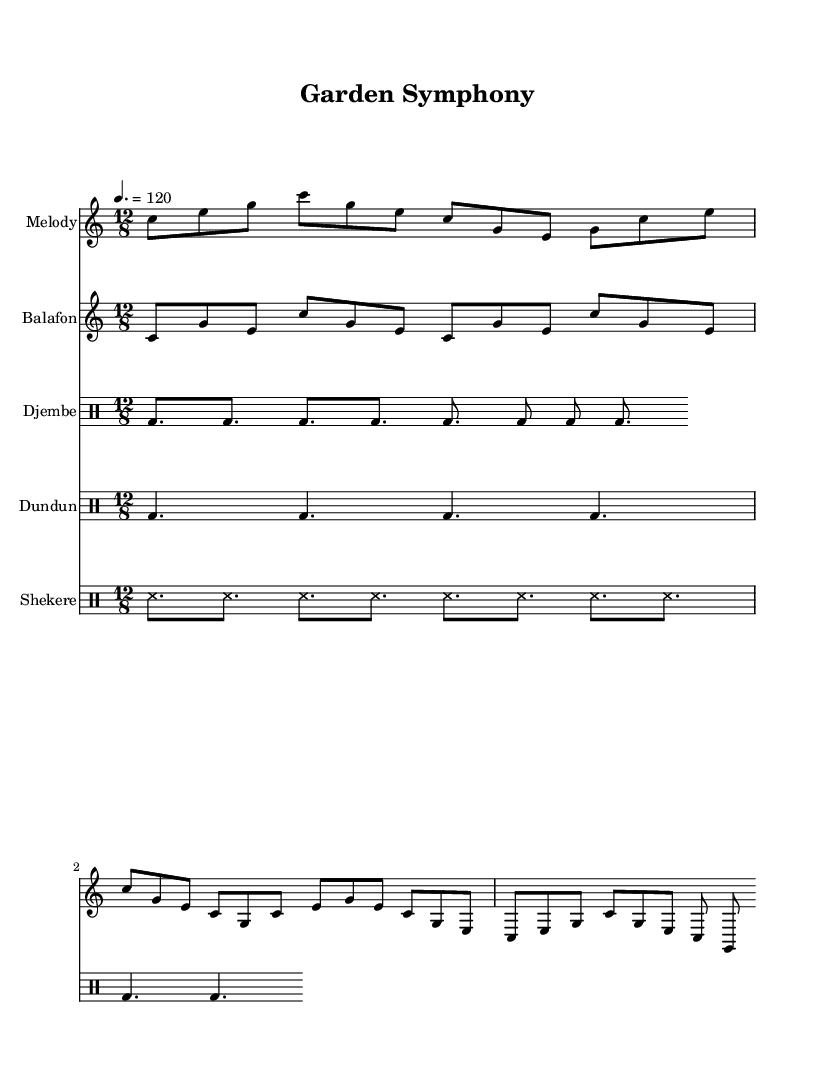What is the key signature of this music? The key signature is C major, which has no sharps or flats.
Answer: C major What is the time signature of this piece? The time signature is 12/8, indicating a compound meter with 12 eighth notes per measure.
Answer: 12/8 What is the tempo marking for this music? The tempo marking indicates a speed of 120 beats per minute, which sets a lively pace for the performance.
Answer: 120 How many different instruments are featured in the score? There are five different instruments featured in the score: Melody, Balafon, Djembe, Dundun, and Shekere, indicating a rich and varied texture.
Answer: Five What is the name of the melodic instrument indicated in the score? The melodic instrument notated is the Balafon, which is a traditional West African percussion instrument with tuned wooden bars.
Answer: Balafon What type of texture does this piece represent? The piece represents a polyphonic texture, where different instruments and melodies play simultaneously, enhancing the celebratory nature of the rhythms.
Answer: Polyphonic 